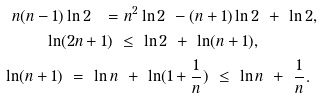<formula> <loc_0><loc_0><loc_500><loc_500>n ( n - 1 ) \ln 2 \ = & \ n ^ { 2 } \ln 2 \ - ( n + 1 ) \ln 2 \ + \ \ln 2 , \\ \ln ( 2 n + 1 ) \ & \leq \ \ln 2 \ + \ \ln ( n + 1 ) , \\ \ln ( n + 1 ) \ = \ \ln n & \ + \ \ln ( 1 + \frac { 1 } { n } ) \ \leq \ \ln n \ + \ \frac { 1 } { n } .</formula> 